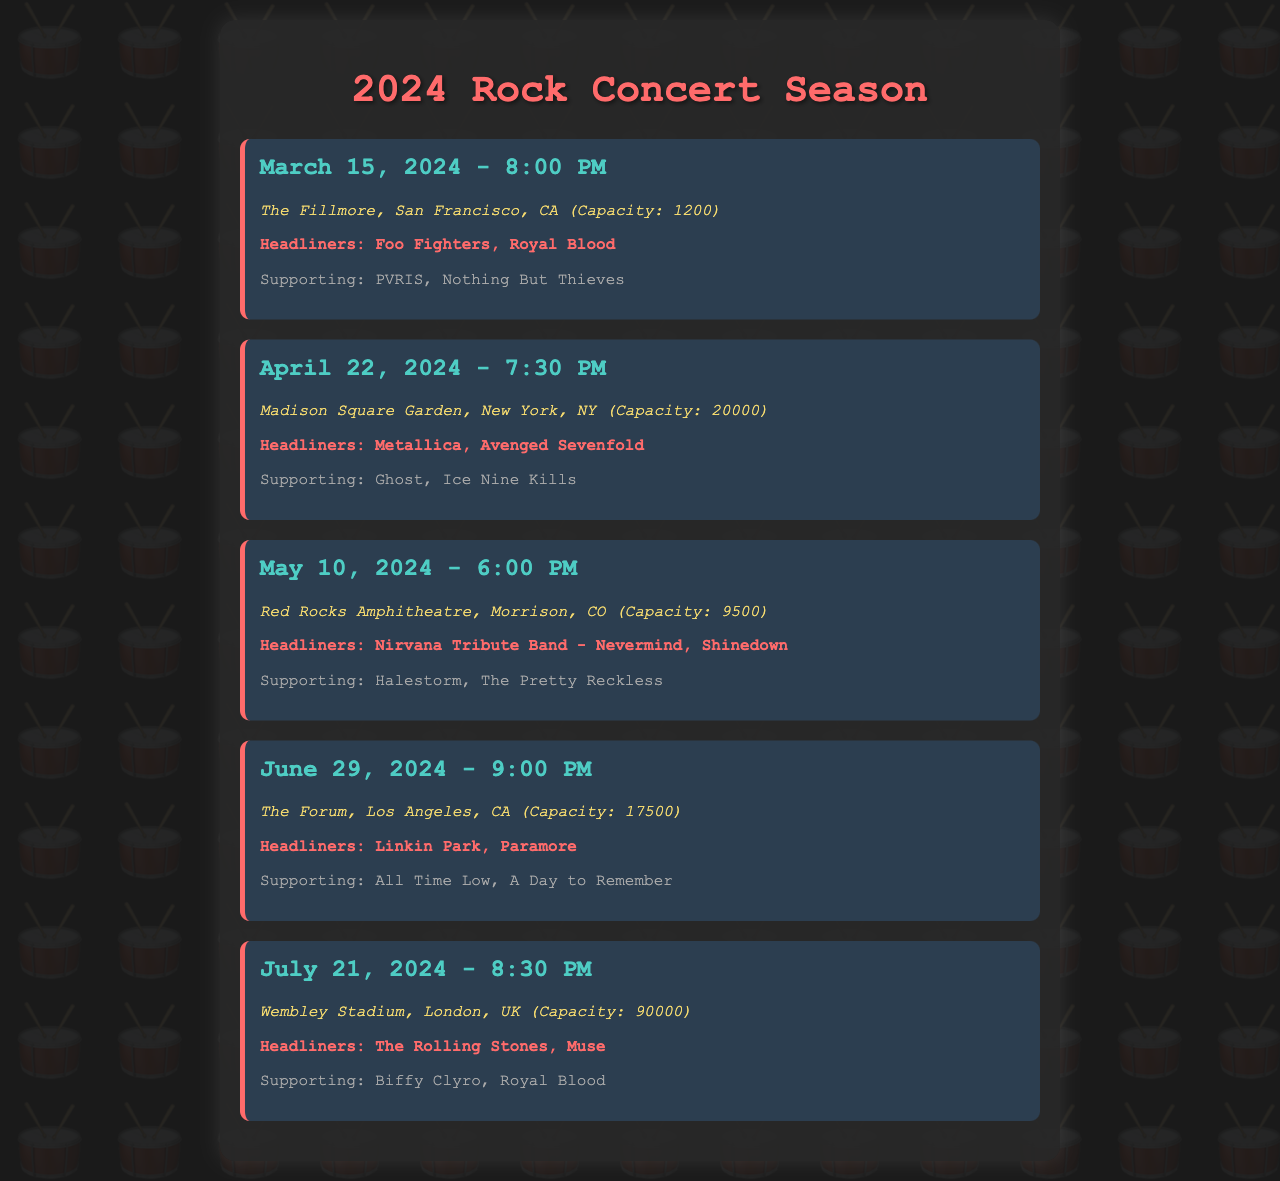What is the capacity of The Fillmore? The capacity is mentioned in the document alongside the venue details.
Answer: 1200 Who are the headliners for the concert on April 22, 2024? The headliners for each concert are listed under the bands section for each date.
Answer: Metallica, Avenged Sevenfold What time does the concert on June 29, 2024, start? The set time for each concert is provided in the date and time heading of each section.
Answer: 9:00 PM Which venue has the largest capacity? By comparing the capacities listed next to each venue, we can determine which is the largest.
Answer: Wembley Stadium How many supporting bands are there for the concert on March 15, 2024? The number of supporting bands is specified in the supporting section for each concert.
Answer: 2 